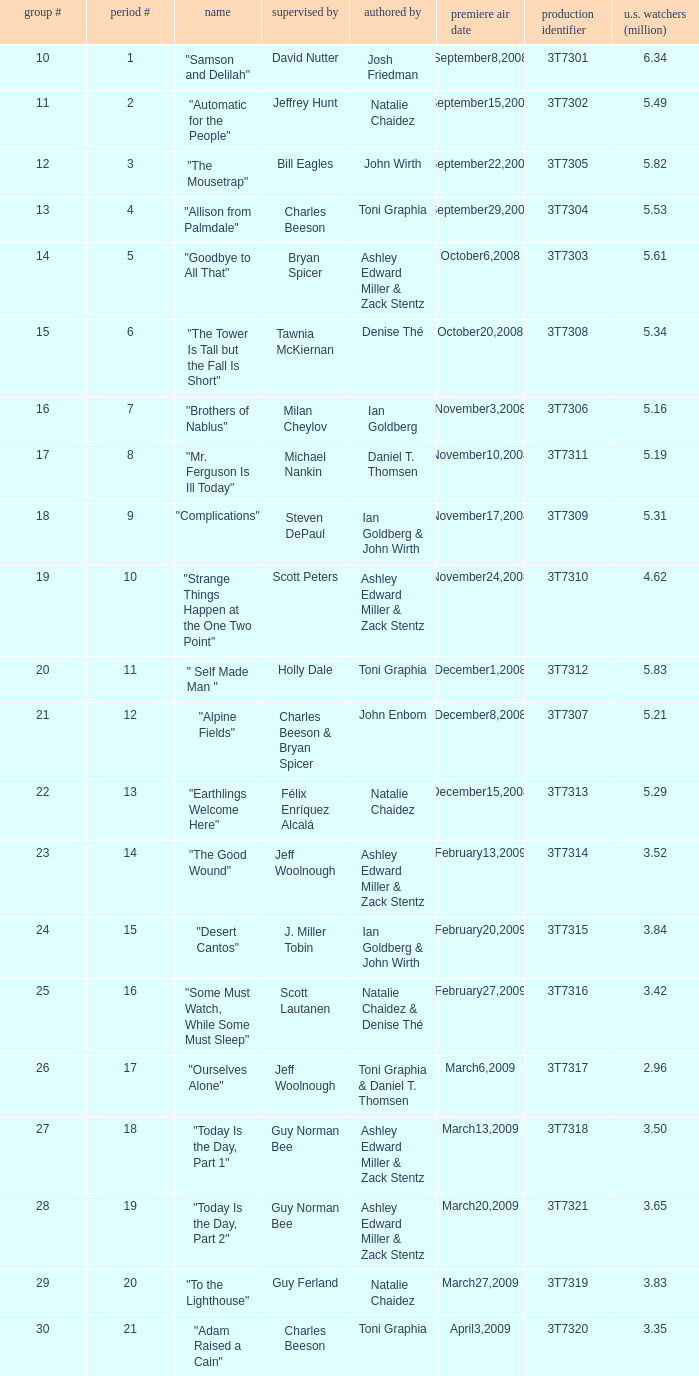Which episode number drew in 3.84 million viewers in the U.S.? 24.0. 